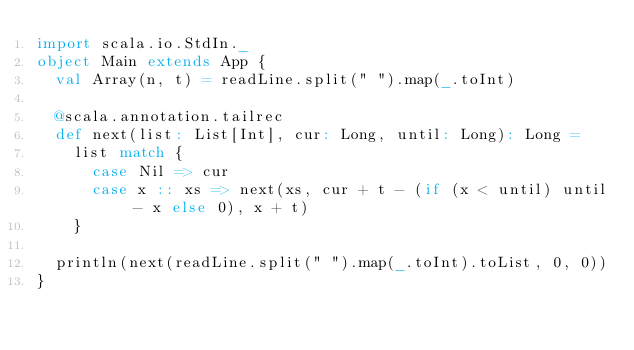Convert code to text. <code><loc_0><loc_0><loc_500><loc_500><_Scala_>import scala.io.StdIn._
object Main extends App {
  val Array(n, t) = readLine.split(" ").map(_.toInt)

  @scala.annotation.tailrec
  def next(list: List[Int], cur: Long, until: Long): Long =
    list match {
      case Nil => cur
      case x :: xs => next(xs, cur + t - (if (x < until) until - x else 0), x + t)
    }

  println(next(readLine.split(" ").map(_.toInt).toList, 0, 0))
}</code> 